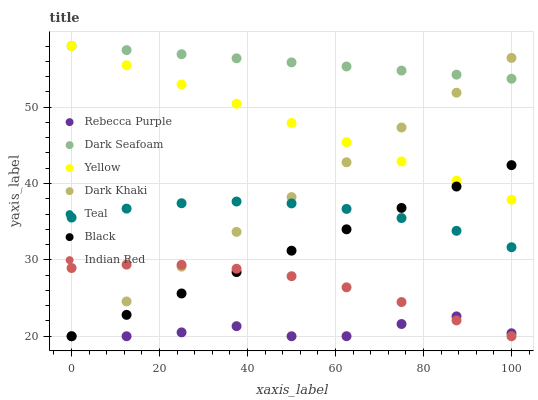Does Rebecca Purple have the minimum area under the curve?
Answer yes or no. Yes. Does Dark Seafoam have the maximum area under the curve?
Answer yes or no. Yes. Does Yellow have the minimum area under the curve?
Answer yes or no. No. Does Yellow have the maximum area under the curve?
Answer yes or no. No. Is Yellow the smoothest?
Answer yes or no. Yes. Is Rebecca Purple the roughest?
Answer yes or no. Yes. Is Dark Khaki the smoothest?
Answer yes or no. No. Is Dark Khaki the roughest?
Answer yes or no. No. Does Indian Red have the lowest value?
Answer yes or no. Yes. Does Yellow have the lowest value?
Answer yes or no. No. Does Dark Seafoam have the highest value?
Answer yes or no. Yes. Does Dark Khaki have the highest value?
Answer yes or no. No. Is Indian Red less than Teal?
Answer yes or no. Yes. Is Yellow greater than Teal?
Answer yes or no. Yes. Does Indian Red intersect Rebecca Purple?
Answer yes or no. Yes. Is Indian Red less than Rebecca Purple?
Answer yes or no. No. Is Indian Red greater than Rebecca Purple?
Answer yes or no. No. Does Indian Red intersect Teal?
Answer yes or no. No. 